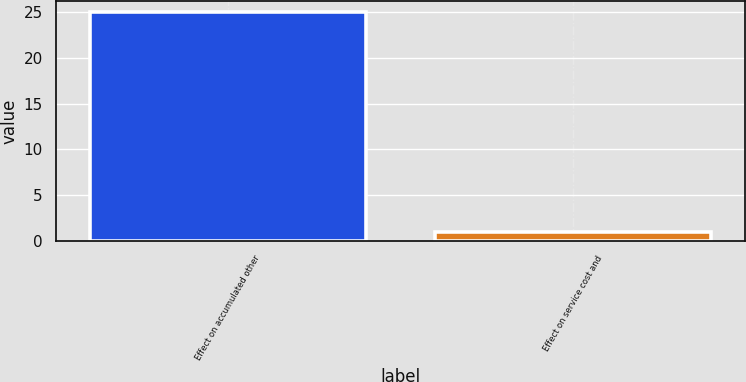Convert chart to OTSL. <chart><loc_0><loc_0><loc_500><loc_500><bar_chart><fcel>Effect on accumulated other<fcel>Effect on service cost and<nl><fcel>25<fcel>1<nl></chart> 